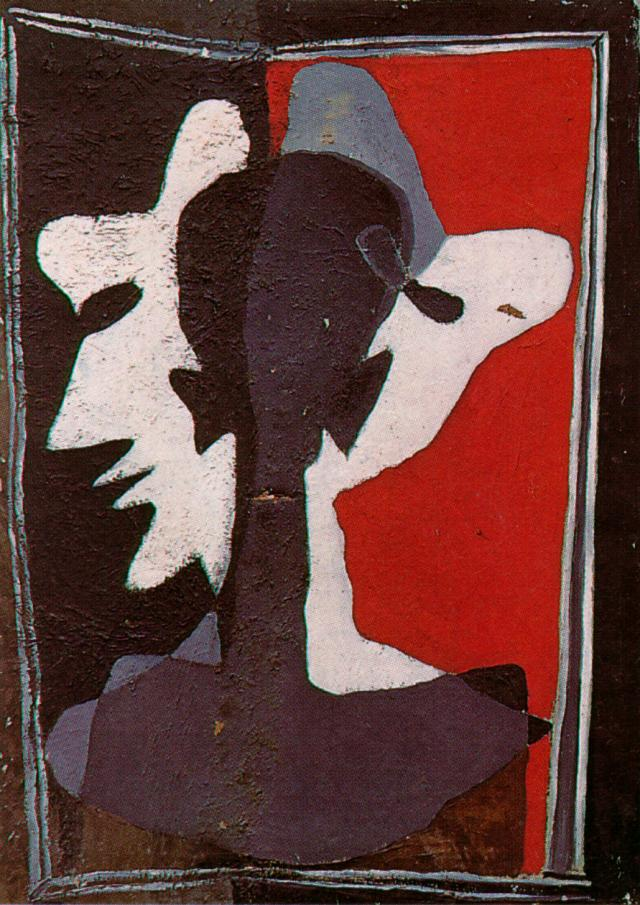Imagine this abstract artwork is a depiction of a scene from a futuristic city. Describe what is happening in this scene. In a bustling futuristic city, the center of activities is marked by a massive digital screen displaying abstract faces that morph and shift continuously, reflecting the ever-changing nature of human identity in a world dominated by technology. The red background represents the energy and vibrancy of the city. The black and white faces symbolize the coexistence of different factions – those who embrace technological advancements and those who resist them. The rough texture of the artwork mirrors the underlying tension between these groups, while the blending forms reflect the interconnectedness of their destinies. 